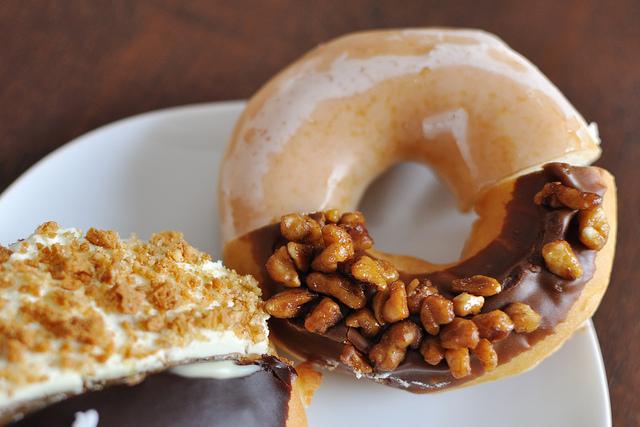Has this donut been tasted?
Concise answer only. No. What color plate is the donut on?
Write a very short answer. White. Is this one whole donut?
Quick response, please. No. 